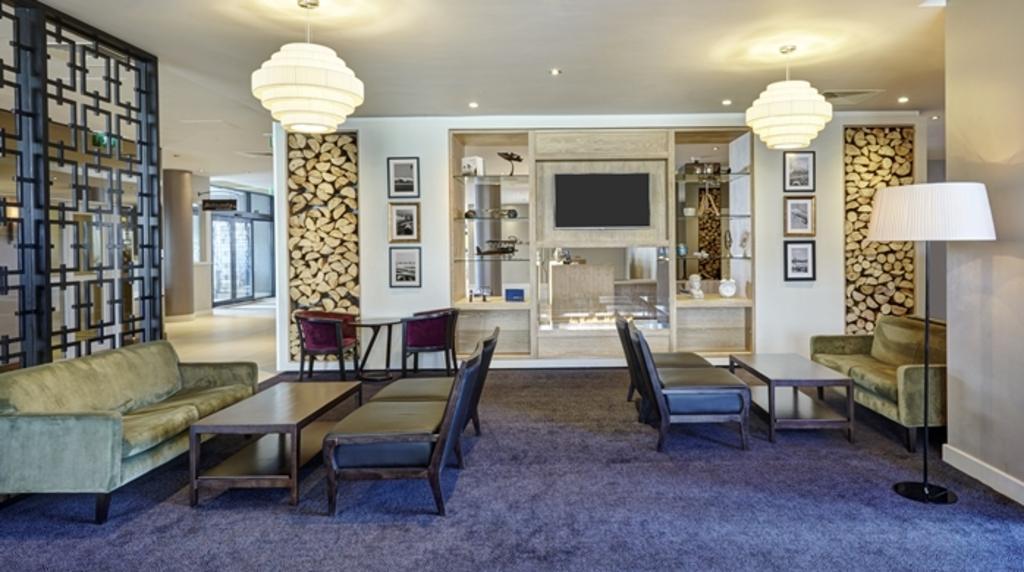Describe this image in one or two sentences. This picture describe about the inside view of the living room, Left side we can see big couch with center table is placed, behind a red color chair and table,beside a big television wall cabinet and in center we can see television, on the left side we can see three photo frame hanging in vertical position and same in right side. In ceiling two chandelier. On the right we can see a couch with center table and standing light. On the left a partition panel of wood can be seen and wall to wall rug on the flooring. 